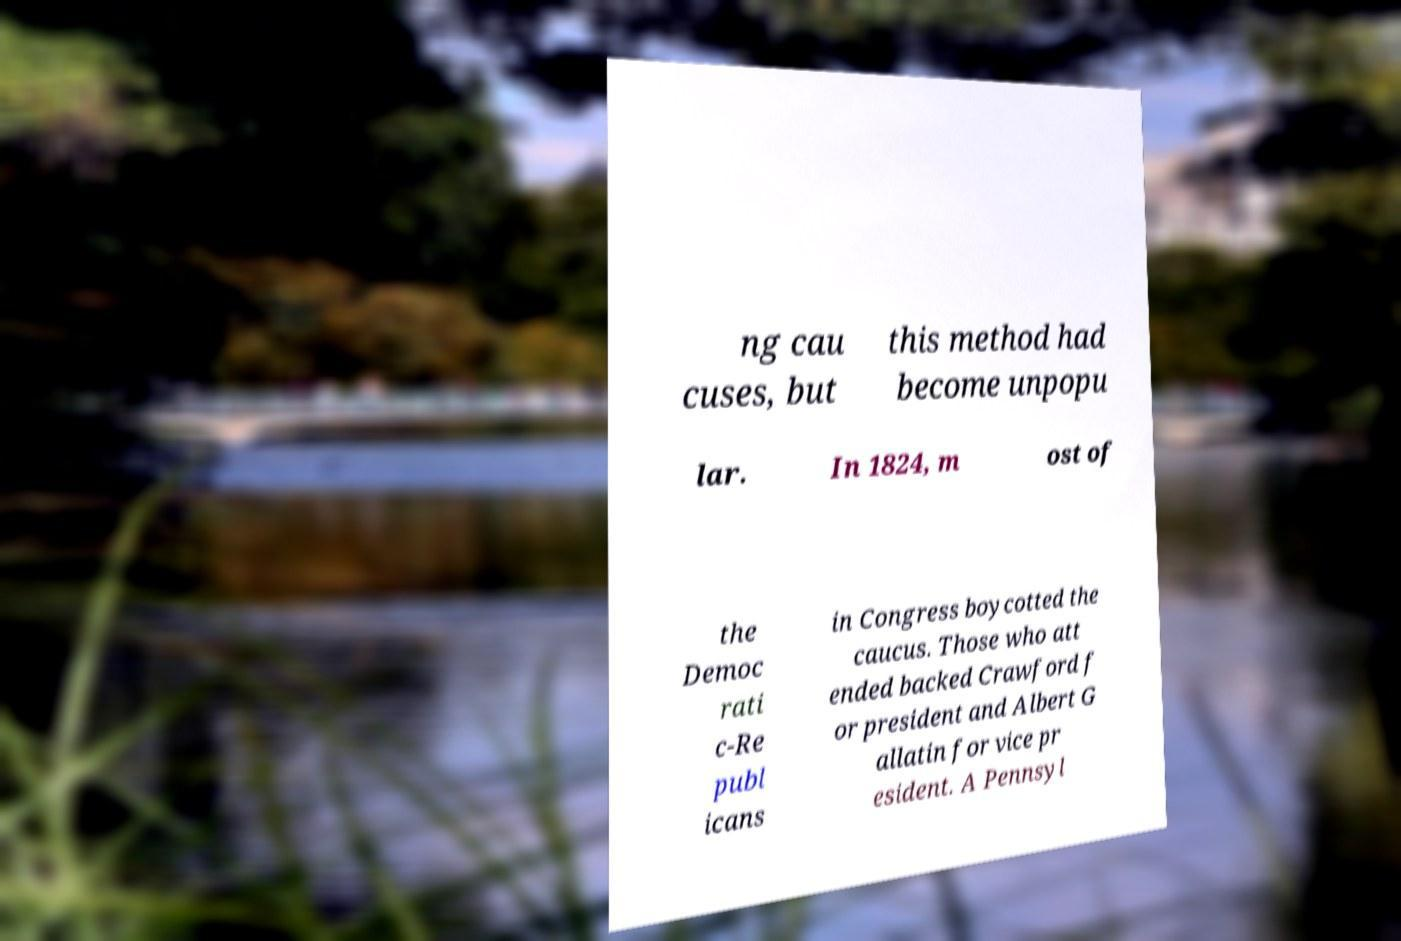Can you read and provide the text displayed in the image?This photo seems to have some interesting text. Can you extract and type it out for me? ng cau cuses, but this method had become unpopu lar. In 1824, m ost of the Democ rati c-Re publ icans in Congress boycotted the caucus. Those who att ended backed Crawford f or president and Albert G allatin for vice pr esident. A Pennsyl 